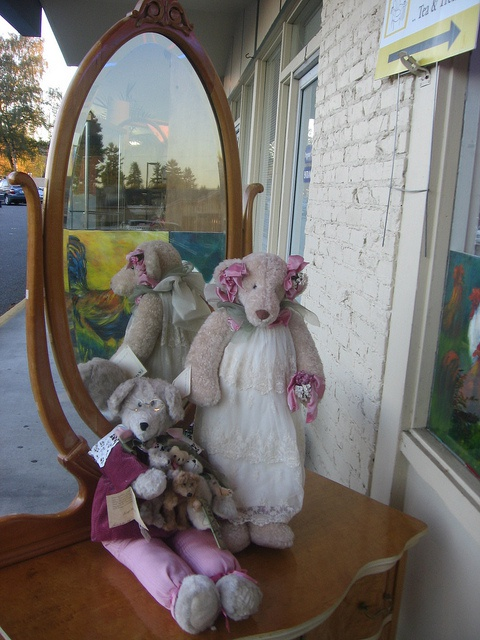Describe the objects in this image and their specific colors. I can see teddy bear in black, darkgray, and gray tones, teddy bear in black, gray, darkgray, and maroon tones, car in black, navy, gray, and darkgray tones, and car in black, darkgray, lightblue, and gray tones in this image. 